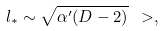<formula> <loc_0><loc_0><loc_500><loc_500>l _ { * } \sim \sqrt { \alpha ^ { \prime } ( D - 2 ) } \ > ,</formula> 